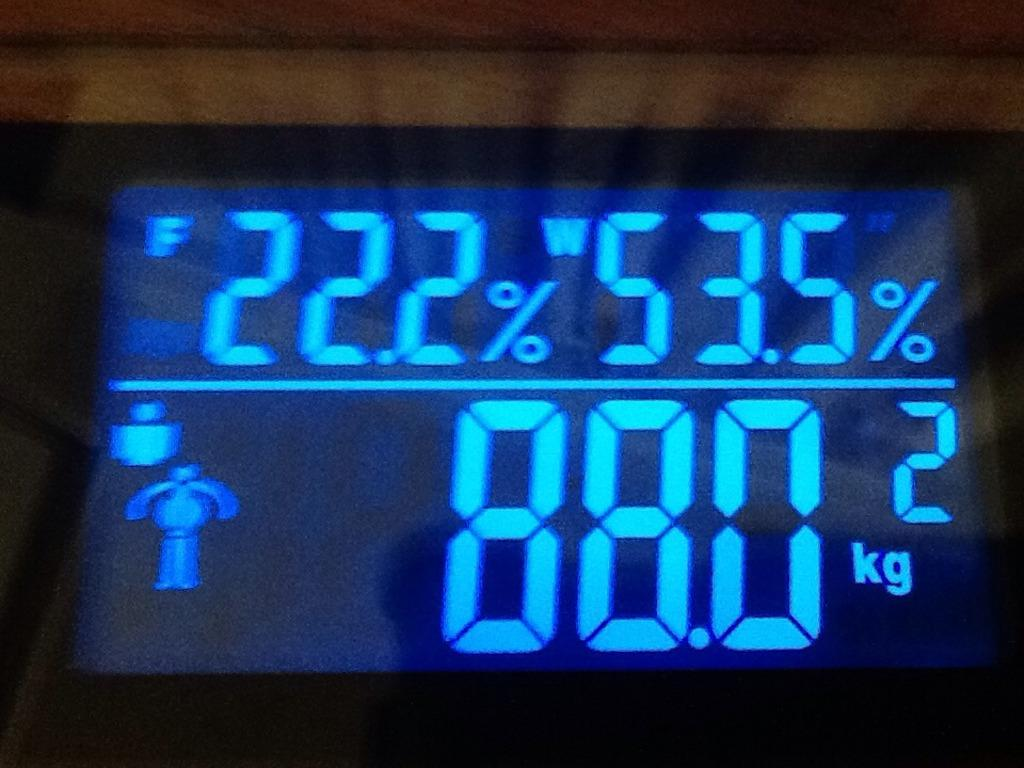<image>
Relay a brief, clear account of the picture shown. a screen with the numbers 88.0 on it 